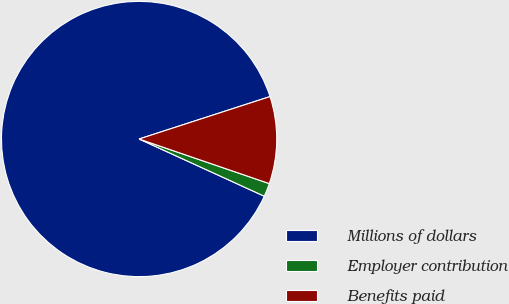<chart> <loc_0><loc_0><loc_500><loc_500><pie_chart><fcel>Millions of dollars<fcel>Employer contribution<fcel>Benefits paid<nl><fcel>88.19%<fcel>1.57%<fcel>10.24%<nl></chart> 